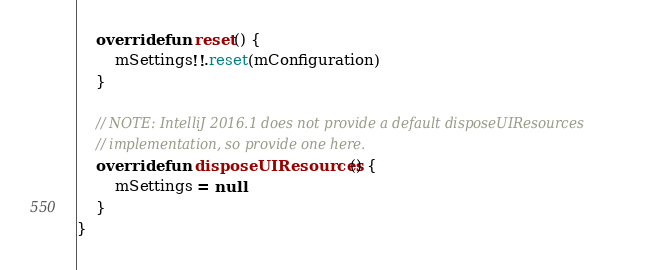<code> <loc_0><loc_0><loc_500><loc_500><_Kotlin_>    override fun reset() {
        mSettings!!.reset(mConfiguration)
    }

    // NOTE: IntelliJ 2016.1 does not provide a default disposeUIResources
    // implementation, so provide one here.
    override fun disposeUIResources() {
        mSettings = null
    }
}
</code> 